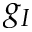Convert formula to latex. <formula><loc_0><loc_0><loc_500><loc_500>g _ { I }</formula> 